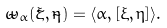<formula> <loc_0><loc_0><loc_500><loc_500>\tilde { \omega } _ { \alpha } ( \tilde { \xi } , \tilde { \eta } ) = \langle \alpha , [ \xi , \eta ] \rangle .</formula> 